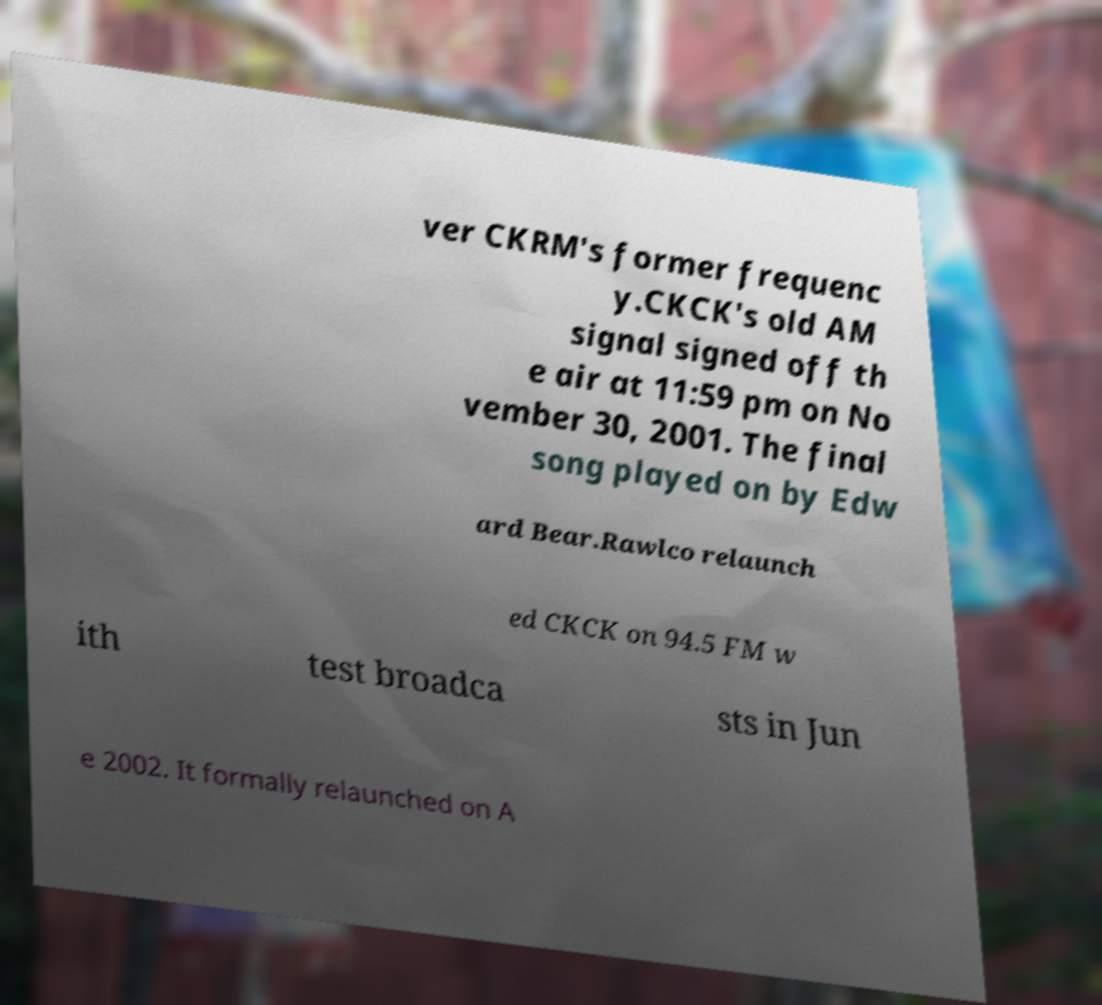I need the written content from this picture converted into text. Can you do that? ver CKRM's former frequenc y.CKCK's old AM signal signed off th e air at 11:59 pm on No vember 30, 2001. The final song played on by Edw ard Bear.Rawlco relaunch ed CKCK on 94.5 FM w ith test broadca sts in Jun e 2002. It formally relaunched on A 